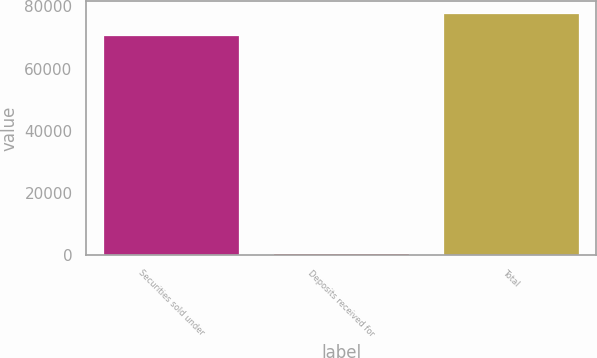Convert chart to OTSL. <chart><loc_0><loc_0><loc_500><loc_500><bar_chart><fcel>Securities sold under<fcel>Deposits received for<fcel>Total<nl><fcel>70850<fcel>774<fcel>77935<nl></chart> 